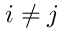<formula> <loc_0><loc_0><loc_500><loc_500>i \neq j</formula> 